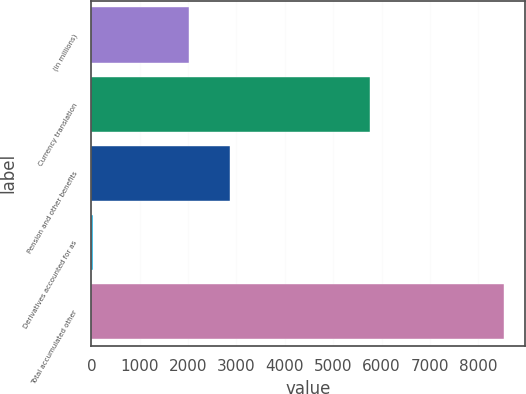Convert chart to OTSL. <chart><loc_0><loc_0><loc_500><loc_500><bar_chart><fcel>(in millions)<fcel>Currency translation<fcel>Pension and other benefits<fcel>Derivatives accounted for as<fcel>Total accumulated other<nl><fcel>2017<fcel>5761<fcel>2866.3<fcel>42<fcel>8535<nl></chart> 